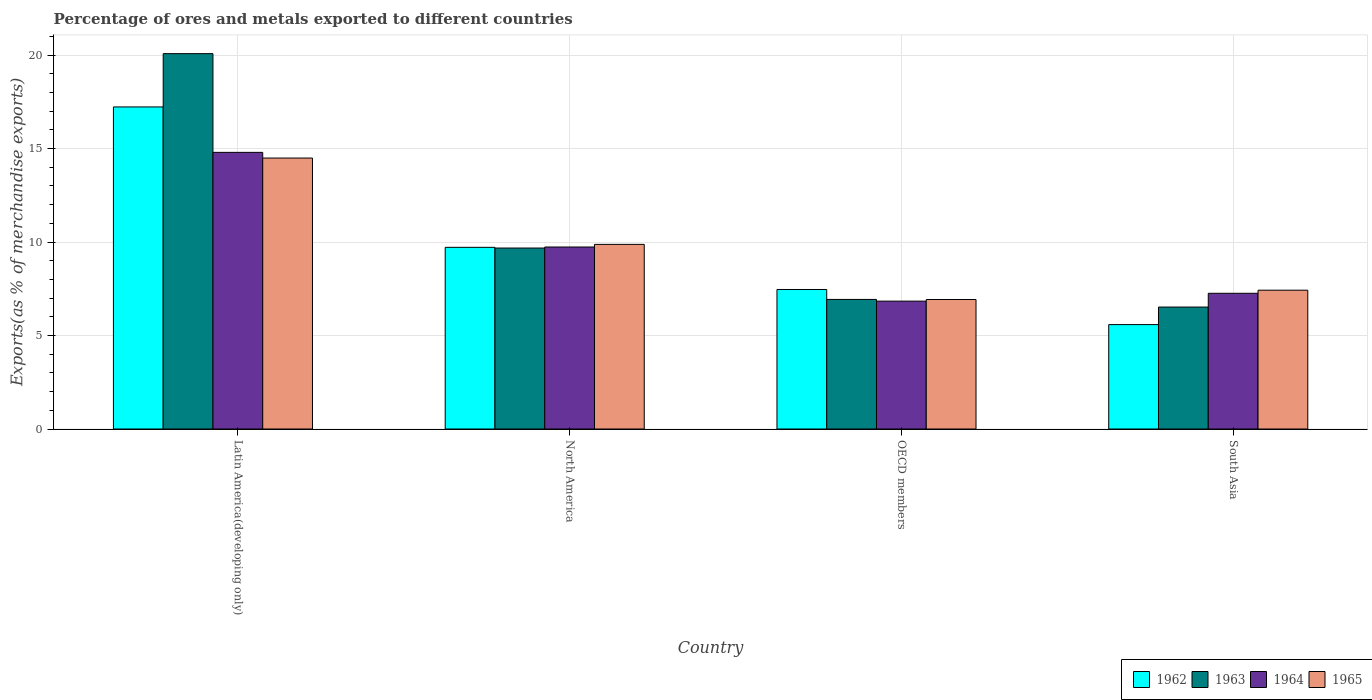How many different coloured bars are there?
Your answer should be compact. 4. Are the number of bars per tick equal to the number of legend labels?
Your answer should be very brief. Yes. Are the number of bars on each tick of the X-axis equal?
Your answer should be very brief. Yes. What is the label of the 2nd group of bars from the left?
Offer a very short reply. North America. In how many cases, is the number of bars for a given country not equal to the number of legend labels?
Offer a very short reply. 0. What is the percentage of exports to different countries in 1962 in OECD members?
Provide a succinct answer. 7.46. Across all countries, what is the maximum percentage of exports to different countries in 1963?
Your answer should be very brief. 20.08. Across all countries, what is the minimum percentage of exports to different countries in 1962?
Your response must be concise. 5.58. In which country was the percentage of exports to different countries in 1965 maximum?
Your response must be concise. Latin America(developing only). What is the total percentage of exports to different countries in 1965 in the graph?
Offer a very short reply. 38.72. What is the difference between the percentage of exports to different countries in 1963 in Latin America(developing only) and that in South Asia?
Keep it short and to the point. 13.55. What is the difference between the percentage of exports to different countries in 1963 in OECD members and the percentage of exports to different countries in 1965 in North America?
Keep it short and to the point. -2.94. What is the average percentage of exports to different countries in 1963 per country?
Your answer should be compact. 10.8. What is the difference between the percentage of exports to different countries of/in 1964 and percentage of exports to different countries of/in 1962 in Latin America(developing only)?
Make the answer very short. -2.43. In how many countries, is the percentage of exports to different countries in 1964 greater than 12 %?
Your answer should be compact. 1. What is the ratio of the percentage of exports to different countries in 1965 in Latin America(developing only) to that in OECD members?
Your answer should be very brief. 2.09. Is the difference between the percentage of exports to different countries in 1964 in Latin America(developing only) and North America greater than the difference between the percentage of exports to different countries in 1962 in Latin America(developing only) and North America?
Ensure brevity in your answer.  No. What is the difference between the highest and the second highest percentage of exports to different countries in 1964?
Your answer should be very brief. -5.06. What is the difference between the highest and the lowest percentage of exports to different countries in 1963?
Provide a succinct answer. 13.55. In how many countries, is the percentage of exports to different countries in 1965 greater than the average percentage of exports to different countries in 1965 taken over all countries?
Offer a terse response. 2. Is the sum of the percentage of exports to different countries in 1962 in Latin America(developing only) and North America greater than the maximum percentage of exports to different countries in 1964 across all countries?
Ensure brevity in your answer.  Yes. Is it the case that in every country, the sum of the percentage of exports to different countries in 1964 and percentage of exports to different countries in 1965 is greater than the sum of percentage of exports to different countries in 1962 and percentage of exports to different countries in 1963?
Give a very brief answer. No. What does the 4th bar from the left in Latin America(developing only) represents?
Keep it short and to the point. 1965. What does the 2nd bar from the right in North America represents?
Offer a terse response. 1964. How many bars are there?
Provide a succinct answer. 16. What is the difference between two consecutive major ticks on the Y-axis?
Offer a very short reply. 5. Does the graph contain grids?
Keep it short and to the point. Yes. Where does the legend appear in the graph?
Make the answer very short. Bottom right. How are the legend labels stacked?
Offer a very short reply. Horizontal. What is the title of the graph?
Make the answer very short. Percentage of ores and metals exported to different countries. Does "1983" appear as one of the legend labels in the graph?
Keep it short and to the point. No. What is the label or title of the X-axis?
Offer a very short reply. Country. What is the label or title of the Y-axis?
Give a very brief answer. Exports(as % of merchandise exports). What is the Exports(as % of merchandise exports) in 1962 in Latin America(developing only)?
Your response must be concise. 17.23. What is the Exports(as % of merchandise exports) in 1963 in Latin America(developing only)?
Ensure brevity in your answer.  20.08. What is the Exports(as % of merchandise exports) in 1964 in Latin America(developing only)?
Offer a terse response. 14.8. What is the Exports(as % of merchandise exports) of 1965 in Latin America(developing only)?
Offer a terse response. 14.49. What is the Exports(as % of merchandise exports) in 1962 in North America?
Offer a very short reply. 9.72. What is the Exports(as % of merchandise exports) of 1963 in North America?
Keep it short and to the point. 9.68. What is the Exports(as % of merchandise exports) in 1964 in North America?
Your response must be concise. 9.73. What is the Exports(as % of merchandise exports) in 1965 in North America?
Give a very brief answer. 9.87. What is the Exports(as % of merchandise exports) in 1962 in OECD members?
Your answer should be compact. 7.46. What is the Exports(as % of merchandise exports) of 1963 in OECD members?
Keep it short and to the point. 6.93. What is the Exports(as % of merchandise exports) of 1964 in OECD members?
Make the answer very short. 6.84. What is the Exports(as % of merchandise exports) in 1965 in OECD members?
Provide a short and direct response. 6.93. What is the Exports(as % of merchandise exports) of 1962 in South Asia?
Give a very brief answer. 5.58. What is the Exports(as % of merchandise exports) of 1963 in South Asia?
Provide a short and direct response. 6.52. What is the Exports(as % of merchandise exports) in 1964 in South Asia?
Make the answer very short. 7.26. What is the Exports(as % of merchandise exports) in 1965 in South Asia?
Your answer should be compact. 7.42. Across all countries, what is the maximum Exports(as % of merchandise exports) in 1962?
Make the answer very short. 17.23. Across all countries, what is the maximum Exports(as % of merchandise exports) of 1963?
Provide a short and direct response. 20.08. Across all countries, what is the maximum Exports(as % of merchandise exports) in 1964?
Your answer should be compact. 14.8. Across all countries, what is the maximum Exports(as % of merchandise exports) in 1965?
Give a very brief answer. 14.49. Across all countries, what is the minimum Exports(as % of merchandise exports) in 1962?
Provide a short and direct response. 5.58. Across all countries, what is the minimum Exports(as % of merchandise exports) in 1963?
Offer a very short reply. 6.52. Across all countries, what is the minimum Exports(as % of merchandise exports) in 1964?
Give a very brief answer. 6.84. Across all countries, what is the minimum Exports(as % of merchandise exports) in 1965?
Offer a very short reply. 6.93. What is the total Exports(as % of merchandise exports) in 1962 in the graph?
Make the answer very short. 39.99. What is the total Exports(as % of merchandise exports) in 1963 in the graph?
Ensure brevity in your answer.  43.21. What is the total Exports(as % of merchandise exports) in 1964 in the graph?
Offer a terse response. 38.63. What is the total Exports(as % of merchandise exports) in 1965 in the graph?
Offer a very short reply. 38.72. What is the difference between the Exports(as % of merchandise exports) of 1962 in Latin America(developing only) and that in North America?
Offer a terse response. 7.51. What is the difference between the Exports(as % of merchandise exports) in 1963 in Latin America(developing only) and that in North America?
Your answer should be compact. 10.4. What is the difference between the Exports(as % of merchandise exports) of 1964 in Latin America(developing only) and that in North America?
Provide a short and direct response. 5.06. What is the difference between the Exports(as % of merchandise exports) in 1965 in Latin America(developing only) and that in North America?
Provide a short and direct response. 4.62. What is the difference between the Exports(as % of merchandise exports) in 1962 in Latin America(developing only) and that in OECD members?
Provide a succinct answer. 9.76. What is the difference between the Exports(as % of merchandise exports) of 1963 in Latin America(developing only) and that in OECD members?
Keep it short and to the point. 13.15. What is the difference between the Exports(as % of merchandise exports) of 1964 in Latin America(developing only) and that in OECD members?
Ensure brevity in your answer.  7.96. What is the difference between the Exports(as % of merchandise exports) in 1965 in Latin America(developing only) and that in OECD members?
Provide a short and direct response. 7.57. What is the difference between the Exports(as % of merchandise exports) in 1962 in Latin America(developing only) and that in South Asia?
Make the answer very short. 11.64. What is the difference between the Exports(as % of merchandise exports) of 1963 in Latin America(developing only) and that in South Asia?
Your answer should be compact. 13.55. What is the difference between the Exports(as % of merchandise exports) in 1964 in Latin America(developing only) and that in South Asia?
Give a very brief answer. 7.54. What is the difference between the Exports(as % of merchandise exports) of 1965 in Latin America(developing only) and that in South Asia?
Your answer should be compact. 7.07. What is the difference between the Exports(as % of merchandise exports) in 1962 in North America and that in OECD members?
Provide a succinct answer. 2.26. What is the difference between the Exports(as % of merchandise exports) of 1963 in North America and that in OECD members?
Your answer should be very brief. 2.75. What is the difference between the Exports(as % of merchandise exports) in 1964 in North America and that in OECD members?
Ensure brevity in your answer.  2.9. What is the difference between the Exports(as % of merchandise exports) of 1965 in North America and that in OECD members?
Your response must be concise. 2.95. What is the difference between the Exports(as % of merchandise exports) of 1962 in North America and that in South Asia?
Offer a very short reply. 4.13. What is the difference between the Exports(as % of merchandise exports) of 1963 in North America and that in South Asia?
Your answer should be compact. 3.16. What is the difference between the Exports(as % of merchandise exports) of 1964 in North America and that in South Asia?
Offer a terse response. 2.48. What is the difference between the Exports(as % of merchandise exports) of 1965 in North America and that in South Asia?
Give a very brief answer. 2.45. What is the difference between the Exports(as % of merchandise exports) in 1962 in OECD members and that in South Asia?
Your answer should be very brief. 1.88. What is the difference between the Exports(as % of merchandise exports) of 1963 in OECD members and that in South Asia?
Offer a very short reply. 0.41. What is the difference between the Exports(as % of merchandise exports) of 1964 in OECD members and that in South Asia?
Provide a short and direct response. -0.42. What is the difference between the Exports(as % of merchandise exports) of 1965 in OECD members and that in South Asia?
Make the answer very short. -0.5. What is the difference between the Exports(as % of merchandise exports) in 1962 in Latin America(developing only) and the Exports(as % of merchandise exports) in 1963 in North America?
Provide a succinct answer. 7.55. What is the difference between the Exports(as % of merchandise exports) in 1962 in Latin America(developing only) and the Exports(as % of merchandise exports) in 1964 in North America?
Your response must be concise. 7.49. What is the difference between the Exports(as % of merchandise exports) in 1962 in Latin America(developing only) and the Exports(as % of merchandise exports) in 1965 in North America?
Keep it short and to the point. 7.35. What is the difference between the Exports(as % of merchandise exports) in 1963 in Latin America(developing only) and the Exports(as % of merchandise exports) in 1964 in North America?
Your answer should be very brief. 10.34. What is the difference between the Exports(as % of merchandise exports) of 1963 in Latin America(developing only) and the Exports(as % of merchandise exports) of 1965 in North America?
Give a very brief answer. 10.2. What is the difference between the Exports(as % of merchandise exports) of 1964 in Latin America(developing only) and the Exports(as % of merchandise exports) of 1965 in North America?
Your answer should be very brief. 4.92. What is the difference between the Exports(as % of merchandise exports) in 1962 in Latin America(developing only) and the Exports(as % of merchandise exports) in 1963 in OECD members?
Provide a short and direct response. 10.3. What is the difference between the Exports(as % of merchandise exports) of 1962 in Latin America(developing only) and the Exports(as % of merchandise exports) of 1964 in OECD members?
Ensure brevity in your answer.  10.39. What is the difference between the Exports(as % of merchandise exports) in 1962 in Latin America(developing only) and the Exports(as % of merchandise exports) in 1965 in OECD members?
Keep it short and to the point. 10.3. What is the difference between the Exports(as % of merchandise exports) in 1963 in Latin America(developing only) and the Exports(as % of merchandise exports) in 1964 in OECD members?
Offer a very short reply. 13.24. What is the difference between the Exports(as % of merchandise exports) in 1963 in Latin America(developing only) and the Exports(as % of merchandise exports) in 1965 in OECD members?
Give a very brief answer. 13.15. What is the difference between the Exports(as % of merchandise exports) of 1964 in Latin America(developing only) and the Exports(as % of merchandise exports) of 1965 in OECD members?
Keep it short and to the point. 7.87. What is the difference between the Exports(as % of merchandise exports) of 1962 in Latin America(developing only) and the Exports(as % of merchandise exports) of 1963 in South Asia?
Provide a succinct answer. 10.7. What is the difference between the Exports(as % of merchandise exports) of 1962 in Latin America(developing only) and the Exports(as % of merchandise exports) of 1964 in South Asia?
Ensure brevity in your answer.  9.97. What is the difference between the Exports(as % of merchandise exports) in 1962 in Latin America(developing only) and the Exports(as % of merchandise exports) in 1965 in South Asia?
Keep it short and to the point. 9.8. What is the difference between the Exports(as % of merchandise exports) of 1963 in Latin America(developing only) and the Exports(as % of merchandise exports) of 1964 in South Asia?
Ensure brevity in your answer.  12.82. What is the difference between the Exports(as % of merchandise exports) in 1963 in Latin America(developing only) and the Exports(as % of merchandise exports) in 1965 in South Asia?
Ensure brevity in your answer.  12.65. What is the difference between the Exports(as % of merchandise exports) of 1964 in Latin America(developing only) and the Exports(as % of merchandise exports) of 1965 in South Asia?
Give a very brief answer. 7.37. What is the difference between the Exports(as % of merchandise exports) of 1962 in North America and the Exports(as % of merchandise exports) of 1963 in OECD members?
Offer a terse response. 2.79. What is the difference between the Exports(as % of merchandise exports) in 1962 in North America and the Exports(as % of merchandise exports) in 1964 in OECD members?
Make the answer very short. 2.88. What is the difference between the Exports(as % of merchandise exports) in 1962 in North America and the Exports(as % of merchandise exports) in 1965 in OECD members?
Ensure brevity in your answer.  2.79. What is the difference between the Exports(as % of merchandise exports) in 1963 in North America and the Exports(as % of merchandise exports) in 1964 in OECD members?
Your answer should be very brief. 2.84. What is the difference between the Exports(as % of merchandise exports) in 1963 in North America and the Exports(as % of merchandise exports) in 1965 in OECD members?
Your response must be concise. 2.75. What is the difference between the Exports(as % of merchandise exports) of 1964 in North America and the Exports(as % of merchandise exports) of 1965 in OECD members?
Make the answer very short. 2.81. What is the difference between the Exports(as % of merchandise exports) of 1962 in North America and the Exports(as % of merchandise exports) of 1963 in South Asia?
Ensure brevity in your answer.  3.19. What is the difference between the Exports(as % of merchandise exports) in 1962 in North America and the Exports(as % of merchandise exports) in 1964 in South Asia?
Make the answer very short. 2.46. What is the difference between the Exports(as % of merchandise exports) of 1962 in North America and the Exports(as % of merchandise exports) of 1965 in South Asia?
Make the answer very short. 2.29. What is the difference between the Exports(as % of merchandise exports) in 1963 in North America and the Exports(as % of merchandise exports) in 1964 in South Asia?
Offer a very short reply. 2.42. What is the difference between the Exports(as % of merchandise exports) of 1963 in North America and the Exports(as % of merchandise exports) of 1965 in South Asia?
Your answer should be compact. 2.25. What is the difference between the Exports(as % of merchandise exports) of 1964 in North America and the Exports(as % of merchandise exports) of 1965 in South Asia?
Keep it short and to the point. 2.31. What is the difference between the Exports(as % of merchandise exports) of 1962 in OECD members and the Exports(as % of merchandise exports) of 1963 in South Asia?
Ensure brevity in your answer.  0.94. What is the difference between the Exports(as % of merchandise exports) of 1962 in OECD members and the Exports(as % of merchandise exports) of 1964 in South Asia?
Offer a terse response. 0.2. What is the difference between the Exports(as % of merchandise exports) in 1962 in OECD members and the Exports(as % of merchandise exports) in 1965 in South Asia?
Keep it short and to the point. 0.04. What is the difference between the Exports(as % of merchandise exports) of 1963 in OECD members and the Exports(as % of merchandise exports) of 1964 in South Asia?
Offer a very short reply. -0.33. What is the difference between the Exports(as % of merchandise exports) of 1963 in OECD members and the Exports(as % of merchandise exports) of 1965 in South Asia?
Provide a short and direct response. -0.49. What is the difference between the Exports(as % of merchandise exports) of 1964 in OECD members and the Exports(as % of merchandise exports) of 1965 in South Asia?
Offer a very short reply. -0.59. What is the average Exports(as % of merchandise exports) of 1962 per country?
Provide a succinct answer. 10. What is the average Exports(as % of merchandise exports) in 1963 per country?
Give a very brief answer. 10.8. What is the average Exports(as % of merchandise exports) of 1964 per country?
Ensure brevity in your answer.  9.66. What is the average Exports(as % of merchandise exports) in 1965 per country?
Provide a short and direct response. 9.68. What is the difference between the Exports(as % of merchandise exports) of 1962 and Exports(as % of merchandise exports) of 1963 in Latin America(developing only)?
Your answer should be very brief. -2.85. What is the difference between the Exports(as % of merchandise exports) in 1962 and Exports(as % of merchandise exports) in 1964 in Latin America(developing only)?
Your answer should be very brief. 2.43. What is the difference between the Exports(as % of merchandise exports) of 1962 and Exports(as % of merchandise exports) of 1965 in Latin America(developing only)?
Your answer should be very brief. 2.73. What is the difference between the Exports(as % of merchandise exports) of 1963 and Exports(as % of merchandise exports) of 1964 in Latin America(developing only)?
Offer a terse response. 5.28. What is the difference between the Exports(as % of merchandise exports) of 1963 and Exports(as % of merchandise exports) of 1965 in Latin America(developing only)?
Make the answer very short. 5.58. What is the difference between the Exports(as % of merchandise exports) of 1964 and Exports(as % of merchandise exports) of 1965 in Latin America(developing only)?
Offer a very short reply. 0.3. What is the difference between the Exports(as % of merchandise exports) of 1962 and Exports(as % of merchandise exports) of 1963 in North America?
Provide a short and direct response. 0.04. What is the difference between the Exports(as % of merchandise exports) of 1962 and Exports(as % of merchandise exports) of 1964 in North America?
Your answer should be very brief. -0.02. What is the difference between the Exports(as % of merchandise exports) of 1962 and Exports(as % of merchandise exports) of 1965 in North America?
Offer a terse response. -0.16. What is the difference between the Exports(as % of merchandise exports) in 1963 and Exports(as % of merchandise exports) in 1964 in North America?
Provide a succinct answer. -0.06. What is the difference between the Exports(as % of merchandise exports) of 1963 and Exports(as % of merchandise exports) of 1965 in North America?
Offer a very short reply. -0.2. What is the difference between the Exports(as % of merchandise exports) in 1964 and Exports(as % of merchandise exports) in 1965 in North America?
Ensure brevity in your answer.  -0.14. What is the difference between the Exports(as % of merchandise exports) of 1962 and Exports(as % of merchandise exports) of 1963 in OECD members?
Offer a very short reply. 0.53. What is the difference between the Exports(as % of merchandise exports) in 1962 and Exports(as % of merchandise exports) in 1964 in OECD members?
Make the answer very short. 0.62. What is the difference between the Exports(as % of merchandise exports) in 1962 and Exports(as % of merchandise exports) in 1965 in OECD members?
Provide a short and direct response. 0.54. What is the difference between the Exports(as % of merchandise exports) in 1963 and Exports(as % of merchandise exports) in 1964 in OECD members?
Your response must be concise. 0.09. What is the difference between the Exports(as % of merchandise exports) in 1963 and Exports(as % of merchandise exports) in 1965 in OECD members?
Offer a terse response. 0. What is the difference between the Exports(as % of merchandise exports) of 1964 and Exports(as % of merchandise exports) of 1965 in OECD members?
Offer a terse response. -0.09. What is the difference between the Exports(as % of merchandise exports) of 1962 and Exports(as % of merchandise exports) of 1963 in South Asia?
Provide a succinct answer. -0.94. What is the difference between the Exports(as % of merchandise exports) of 1962 and Exports(as % of merchandise exports) of 1964 in South Asia?
Your response must be concise. -1.68. What is the difference between the Exports(as % of merchandise exports) of 1962 and Exports(as % of merchandise exports) of 1965 in South Asia?
Make the answer very short. -1.84. What is the difference between the Exports(as % of merchandise exports) in 1963 and Exports(as % of merchandise exports) in 1964 in South Asia?
Offer a very short reply. -0.74. What is the difference between the Exports(as % of merchandise exports) of 1963 and Exports(as % of merchandise exports) of 1965 in South Asia?
Provide a succinct answer. -0.9. What is the difference between the Exports(as % of merchandise exports) of 1964 and Exports(as % of merchandise exports) of 1965 in South Asia?
Offer a terse response. -0.17. What is the ratio of the Exports(as % of merchandise exports) of 1962 in Latin America(developing only) to that in North America?
Ensure brevity in your answer.  1.77. What is the ratio of the Exports(as % of merchandise exports) of 1963 in Latin America(developing only) to that in North America?
Keep it short and to the point. 2.07. What is the ratio of the Exports(as % of merchandise exports) of 1964 in Latin America(developing only) to that in North America?
Your answer should be very brief. 1.52. What is the ratio of the Exports(as % of merchandise exports) of 1965 in Latin America(developing only) to that in North America?
Provide a succinct answer. 1.47. What is the ratio of the Exports(as % of merchandise exports) in 1962 in Latin America(developing only) to that in OECD members?
Your response must be concise. 2.31. What is the ratio of the Exports(as % of merchandise exports) in 1963 in Latin America(developing only) to that in OECD members?
Your response must be concise. 2.9. What is the ratio of the Exports(as % of merchandise exports) in 1964 in Latin America(developing only) to that in OECD members?
Offer a terse response. 2.16. What is the ratio of the Exports(as % of merchandise exports) of 1965 in Latin America(developing only) to that in OECD members?
Ensure brevity in your answer.  2.09. What is the ratio of the Exports(as % of merchandise exports) of 1962 in Latin America(developing only) to that in South Asia?
Your answer should be very brief. 3.08. What is the ratio of the Exports(as % of merchandise exports) in 1963 in Latin America(developing only) to that in South Asia?
Make the answer very short. 3.08. What is the ratio of the Exports(as % of merchandise exports) in 1964 in Latin America(developing only) to that in South Asia?
Your answer should be compact. 2.04. What is the ratio of the Exports(as % of merchandise exports) in 1965 in Latin America(developing only) to that in South Asia?
Your answer should be very brief. 1.95. What is the ratio of the Exports(as % of merchandise exports) of 1962 in North America to that in OECD members?
Your response must be concise. 1.3. What is the ratio of the Exports(as % of merchandise exports) of 1963 in North America to that in OECD members?
Ensure brevity in your answer.  1.4. What is the ratio of the Exports(as % of merchandise exports) in 1964 in North America to that in OECD members?
Your answer should be very brief. 1.42. What is the ratio of the Exports(as % of merchandise exports) in 1965 in North America to that in OECD members?
Make the answer very short. 1.43. What is the ratio of the Exports(as % of merchandise exports) of 1962 in North America to that in South Asia?
Provide a succinct answer. 1.74. What is the ratio of the Exports(as % of merchandise exports) in 1963 in North America to that in South Asia?
Provide a succinct answer. 1.48. What is the ratio of the Exports(as % of merchandise exports) of 1964 in North America to that in South Asia?
Ensure brevity in your answer.  1.34. What is the ratio of the Exports(as % of merchandise exports) of 1965 in North America to that in South Asia?
Your answer should be compact. 1.33. What is the ratio of the Exports(as % of merchandise exports) in 1962 in OECD members to that in South Asia?
Provide a succinct answer. 1.34. What is the ratio of the Exports(as % of merchandise exports) in 1963 in OECD members to that in South Asia?
Provide a short and direct response. 1.06. What is the ratio of the Exports(as % of merchandise exports) of 1964 in OECD members to that in South Asia?
Keep it short and to the point. 0.94. What is the ratio of the Exports(as % of merchandise exports) of 1965 in OECD members to that in South Asia?
Offer a terse response. 0.93. What is the difference between the highest and the second highest Exports(as % of merchandise exports) in 1962?
Your answer should be compact. 7.51. What is the difference between the highest and the second highest Exports(as % of merchandise exports) in 1963?
Keep it short and to the point. 10.4. What is the difference between the highest and the second highest Exports(as % of merchandise exports) of 1964?
Your answer should be compact. 5.06. What is the difference between the highest and the second highest Exports(as % of merchandise exports) in 1965?
Offer a very short reply. 4.62. What is the difference between the highest and the lowest Exports(as % of merchandise exports) in 1962?
Ensure brevity in your answer.  11.64. What is the difference between the highest and the lowest Exports(as % of merchandise exports) in 1963?
Offer a terse response. 13.55. What is the difference between the highest and the lowest Exports(as % of merchandise exports) in 1964?
Your answer should be very brief. 7.96. What is the difference between the highest and the lowest Exports(as % of merchandise exports) in 1965?
Ensure brevity in your answer.  7.57. 